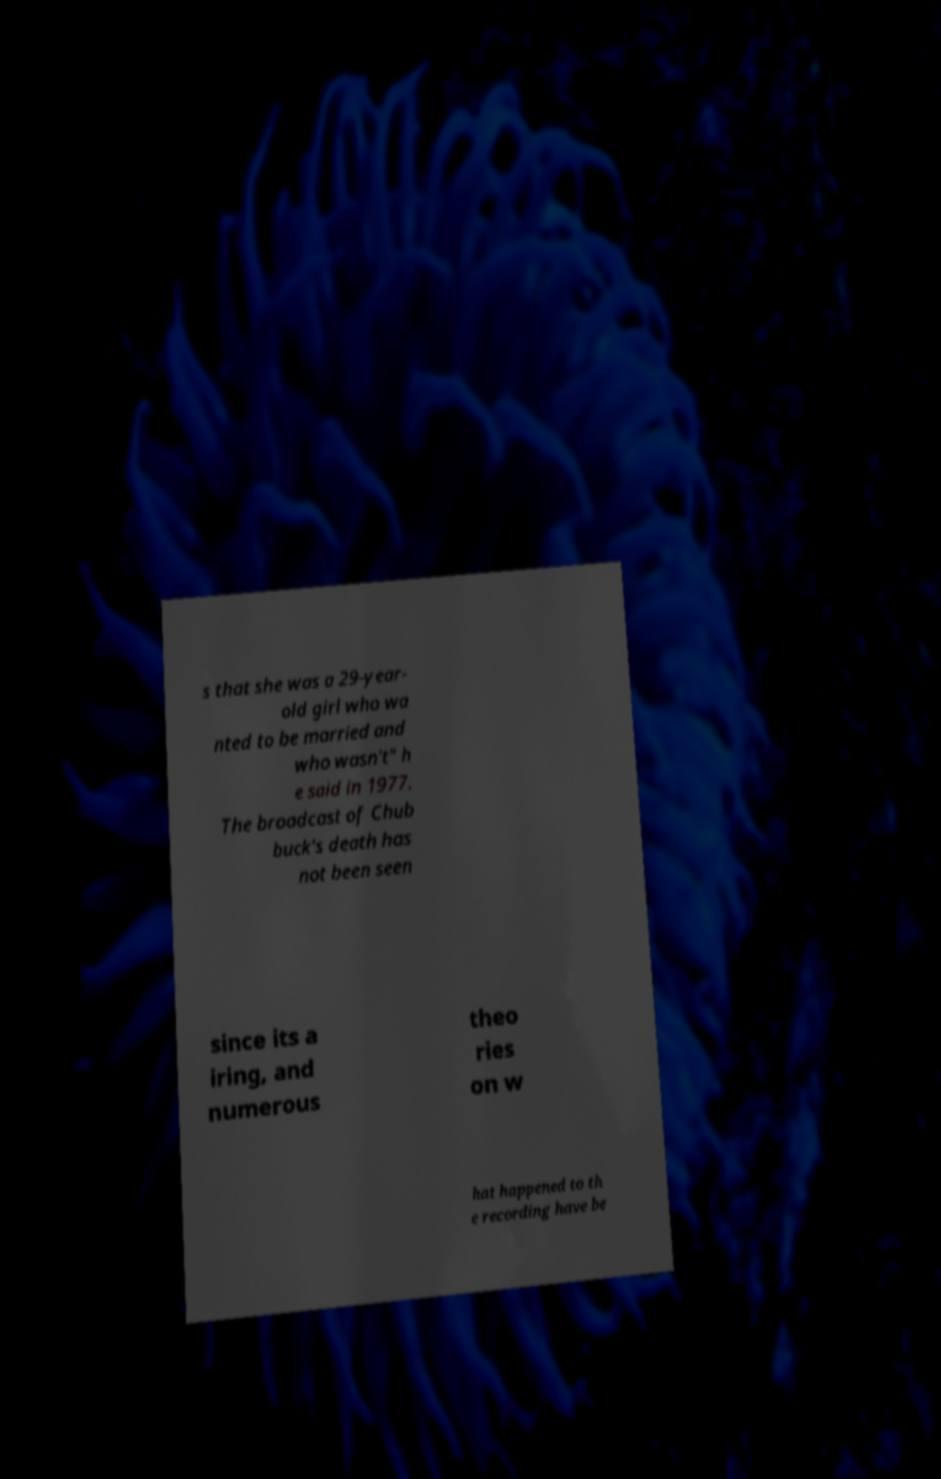There's text embedded in this image that I need extracted. Can you transcribe it verbatim? s that she was a 29-year- old girl who wa nted to be married and who wasn't" h e said in 1977. The broadcast of Chub buck's death has not been seen since its a iring, and numerous theo ries on w hat happened to th e recording have be 